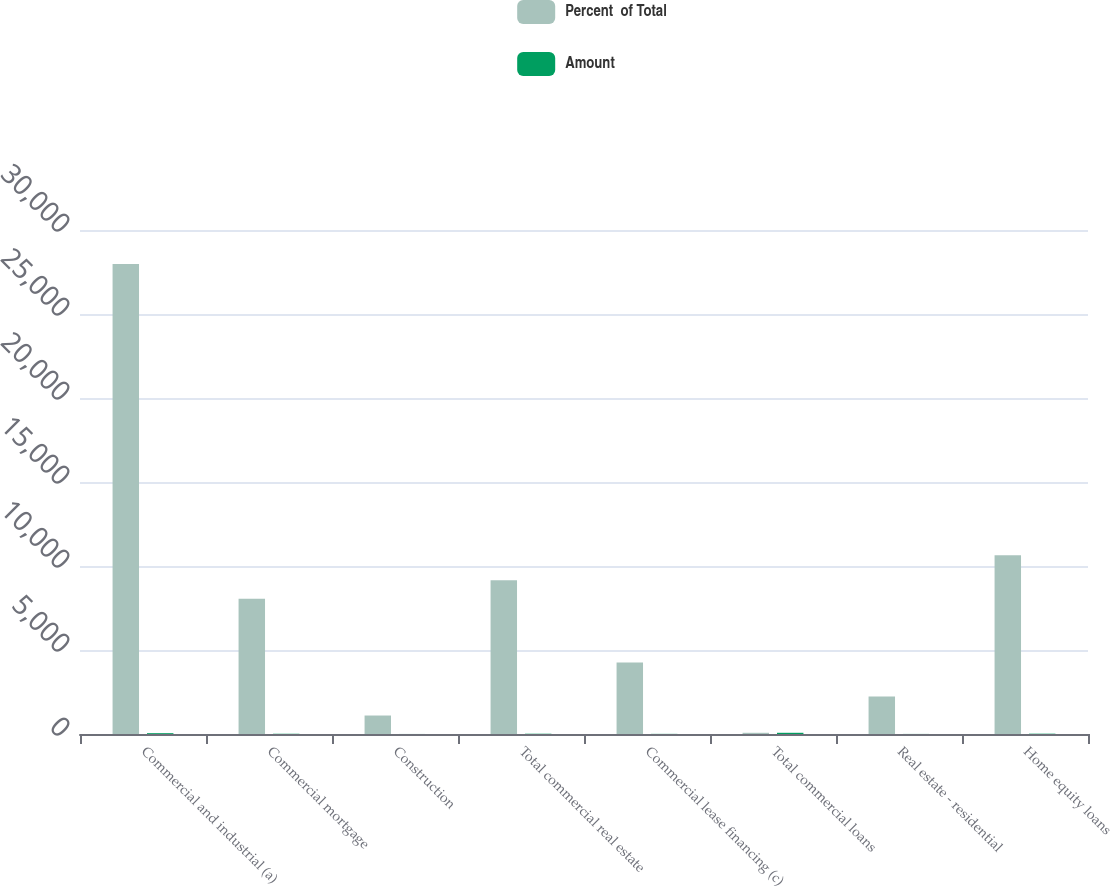<chart> <loc_0><loc_0><loc_500><loc_500><stacked_bar_chart><ecel><fcel>Commercial and industrial (a)<fcel>Commercial mortgage<fcel>Construction<fcel>Total commercial real estate<fcel>Commercial lease financing (c)<fcel>Total commercial loans<fcel>Real estate - residential<fcel>Home equity loans<nl><fcel>Percent  of Total<fcel>27982<fcel>8047<fcel>1100<fcel>9147<fcel>4252<fcel>72.1<fcel>2225<fcel>10633<nl><fcel>Amount<fcel>48.8<fcel>14<fcel>1.9<fcel>15.9<fcel>7.4<fcel>72.1<fcel>3.9<fcel>18.6<nl></chart> 